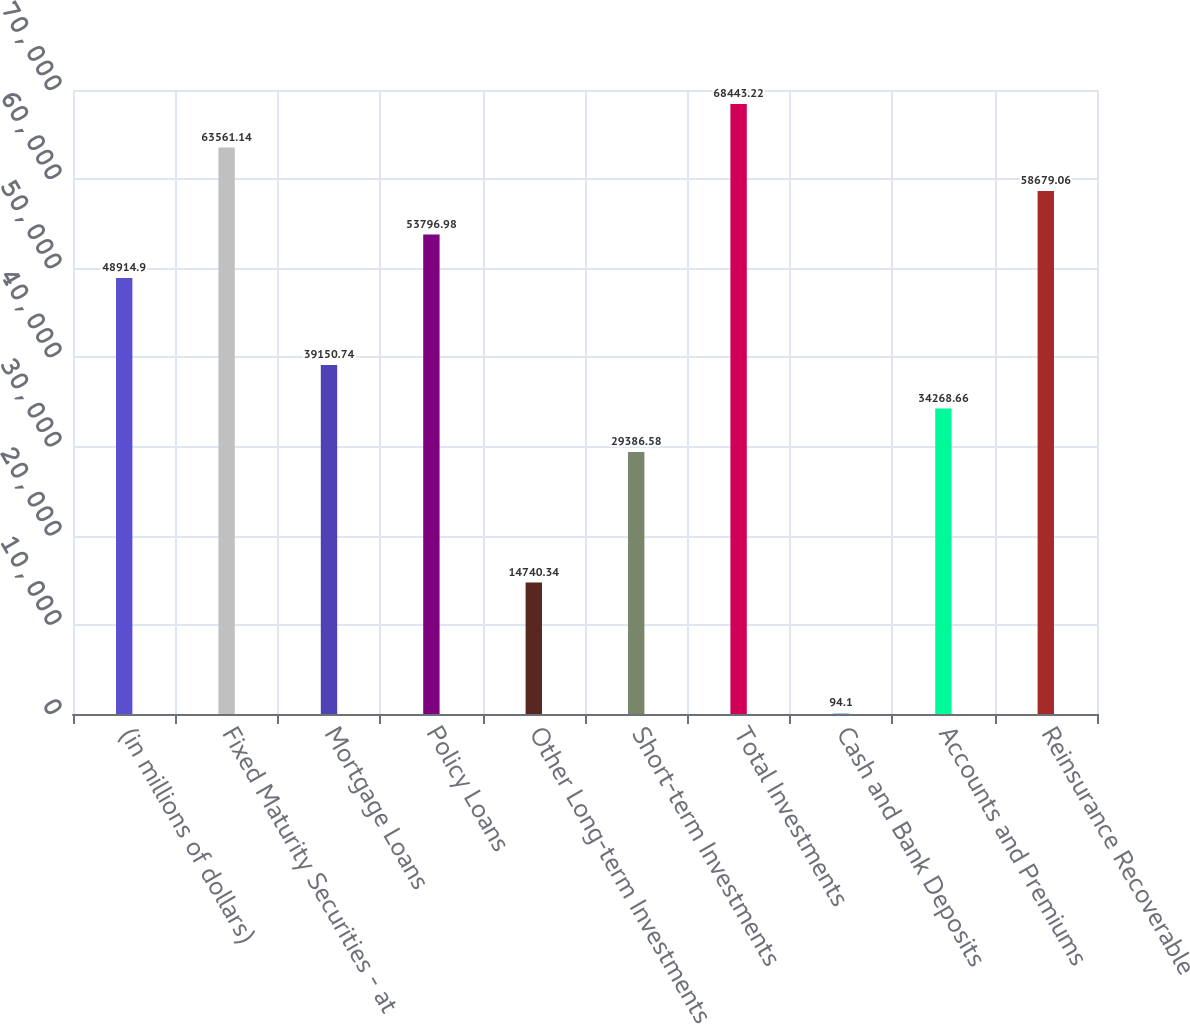Convert chart. <chart><loc_0><loc_0><loc_500><loc_500><bar_chart><fcel>(in millions of dollars)<fcel>Fixed Maturity Securities - at<fcel>Mortgage Loans<fcel>Policy Loans<fcel>Other Long-term Investments<fcel>Short-term Investments<fcel>Total Investments<fcel>Cash and Bank Deposits<fcel>Accounts and Premiums<fcel>Reinsurance Recoverable<nl><fcel>48914.9<fcel>63561.1<fcel>39150.7<fcel>53797<fcel>14740.3<fcel>29386.6<fcel>68443.2<fcel>94.1<fcel>34268.7<fcel>58679.1<nl></chart> 